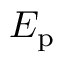<formula> <loc_0><loc_0><loc_500><loc_500>E _ { p }</formula> 